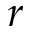<formula> <loc_0><loc_0><loc_500><loc_500>r</formula> 